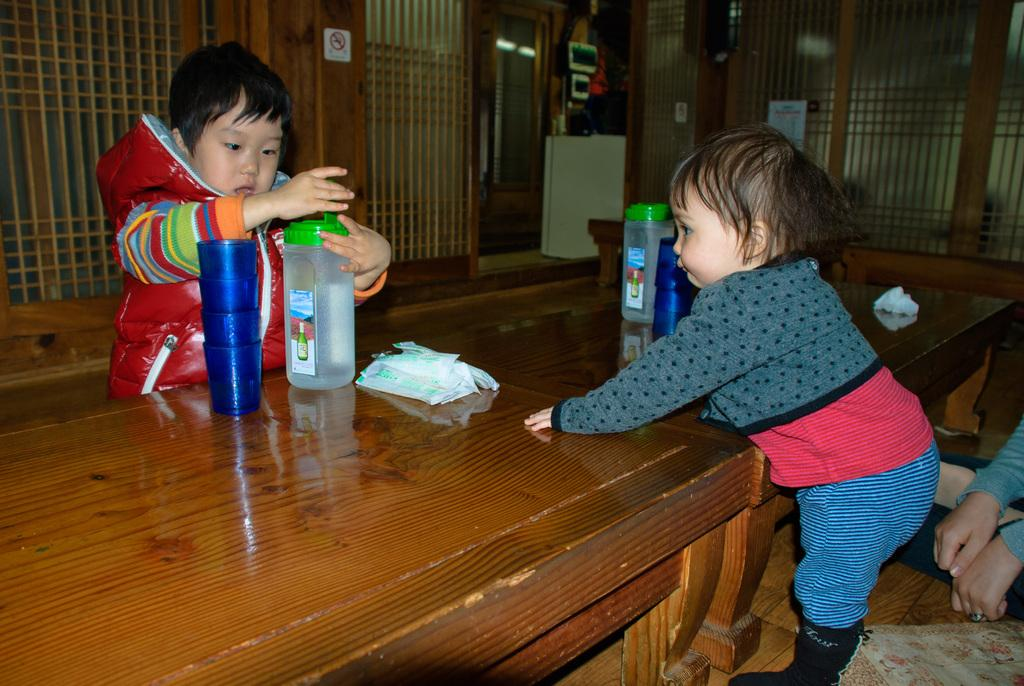How many individuals are present in the image? There are three people in the image. Can you describe the age group of the people in the image? There are two kids in the image. What objects can be seen on the table in the image? There are glasses and bottles on the table. What type of coastline can be seen in the image? There is no coastline present in the image. Is there a beggar visible in the image? There is no beggar present in the image. 